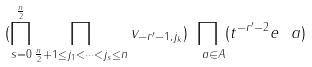<formula> <loc_0><loc_0><loc_500><loc_500>( \prod _ { s = 0 } ^ { \frac { n } { 2 } } \prod _ { \frac { n } { 2 } + 1 \leq j _ { 1 } < \dots < j _ { s } \leq n } v _ { - r ^ { \prime } - 1 , j _ { k } } ) \prod _ { \ a \in A } ( t ^ { - r ^ { \prime } - 2 } e _ { \ } a )</formula> 